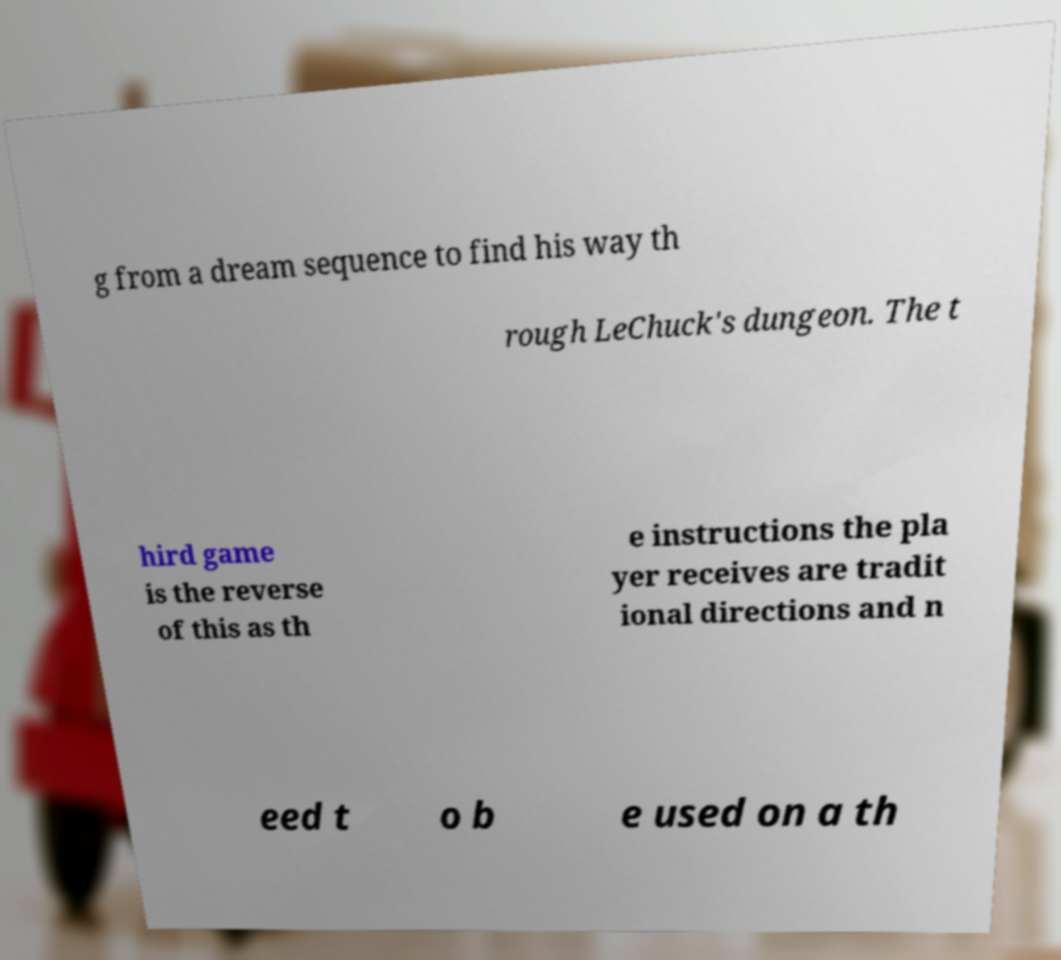I need the written content from this picture converted into text. Can you do that? g from a dream sequence to find his way th rough LeChuck's dungeon. The t hird game is the reverse of this as th e instructions the pla yer receives are tradit ional directions and n eed t o b e used on a th 